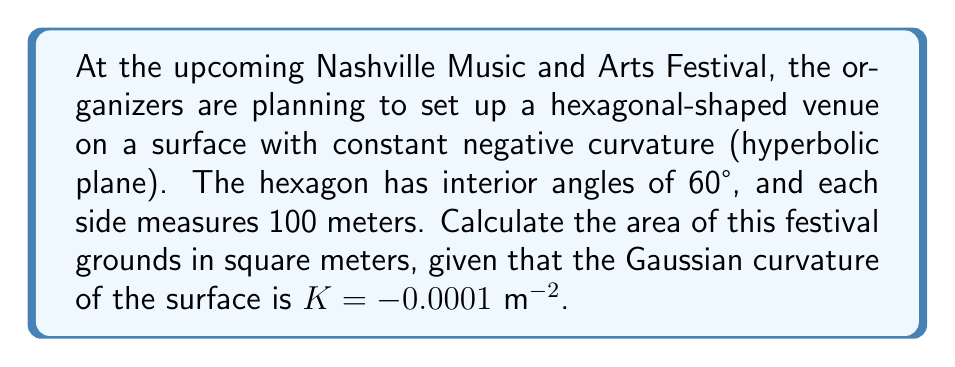Give your solution to this math problem. To solve this problem, we'll use the Gauss-Bonnet theorem for hyperbolic geometry. The steps are as follows:

1) In hyperbolic geometry, the area of a polygon is given by:

   $$A = (2\pi - \sum_{i=1}^n \theta_i) \cdot \frac{1}{|K|}$$

   where $\theta_i$ are the interior angles of the polygon, $n$ is the number of sides, and $K$ is the Gaussian curvature.

2) For our hexagon, we have:
   - $n = 6$ sides
   - Each interior angle $\theta_i = 60° = \frac{\pi}{3}$ radians
   - $K = -0.0001$ m^(-2)

3) Let's calculate $\sum_{i=1}^n \theta_i$:

   $$\sum_{i=1}^6 \theta_i = 6 \cdot \frac{\pi}{3} = 2\pi$$

4) Now, let's substitute these values into our area formula:

   $$A = (2\pi - 2\pi) \cdot \frac{1}{|-0.0001|}$$

5) Simplify:

   $$A = 0 \cdot 10000 = 0 \text{ m}^2$$

This result might seem counterintuitive, but it's correct. In hyperbolic geometry, the sum of the angles in a hexagon is always less than $6\pi/3 = 2\pi$. The fact that our hexagon has a sum of exactly $2\pi$ means it's actually a limiting case between hyperbolic and Euclidean geometry, resulting in zero hyperbolic area.
Answer: 0 m² 